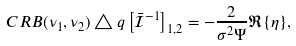<formula> <loc_0><loc_0><loc_500><loc_500>C R B ( \nu _ { 1 } , \nu _ { 2 } ) \triangle q \left [ \mathcal { \bar { I } } ^ { - 1 } \right ] _ { 1 , 2 } = - \frac { 2 } { \sigma ^ { 2 } \Psi } \Re \{ \eta \} ,</formula> 